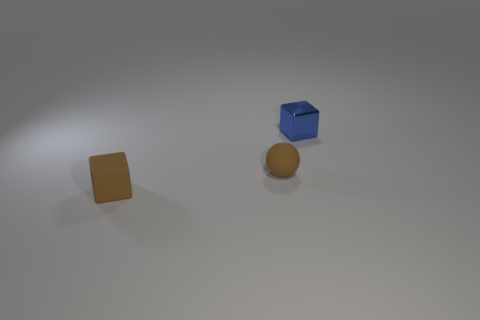Is there anything else that has the same material as the blue thing?
Your response must be concise. No. Is the color of the ball the same as the rubber block?
Give a very brief answer. Yes. Does the rubber cube have the same size as the matte sphere?
Your answer should be compact. Yes. What is the color of the thing that is both right of the small brown rubber cube and to the left of the tiny blue thing?
Offer a very short reply. Brown. How many brown blocks have the same material as the tiny ball?
Provide a succinct answer. 1. How many tiny blue metal blocks are there?
Your answer should be very brief. 1. The tiny brown object to the right of the cube that is left of the small blue block is made of what material?
Make the answer very short. Rubber. There is a brown matte thing in front of the brown matte object right of the small block in front of the blue metallic thing; what size is it?
Provide a short and direct response. Small. Does the shiny thing have the same shape as the small brown thing that is right of the rubber block?
Your answer should be compact. No. What is the material of the brown sphere?
Ensure brevity in your answer.  Rubber. 